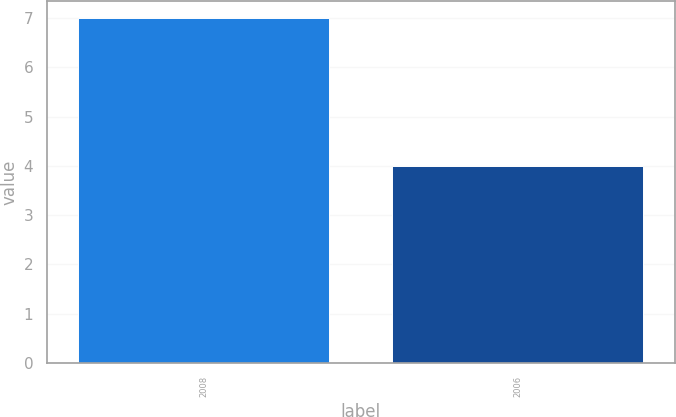Convert chart. <chart><loc_0><loc_0><loc_500><loc_500><bar_chart><fcel>2008<fcel>2006<nl><fcel>7<fcel>4<nl></chart> 